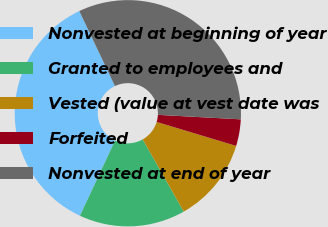Convert chart to OTSL. <chart><loc_0><loc_0><loc_500><loc_500><pie_chart><fcel>Nonvested at beginning of year<fcel>Granted to employees and<fcel>Vested (value at vest date was<fcel>Forfeited<fcel>Nonvested at end of year<nl><fcel>35.99%<fcel>15.18%<fcel>12.11%<fcel>3.8%<fcel>32.92%<nl></chart> 